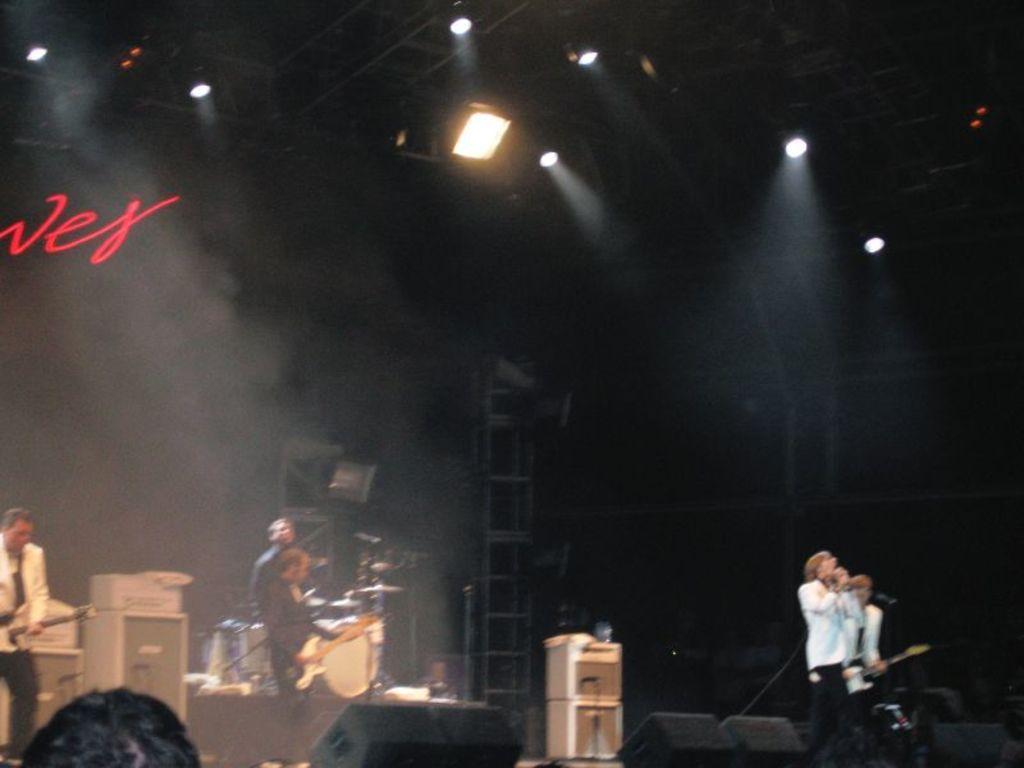Could you give a brief overview of what you see in this image? In this picture we can see some people playing musical instrument such as guitar, drums and singing on mic on stage and in front of them we can see lights and in background pillar and it is dark. 